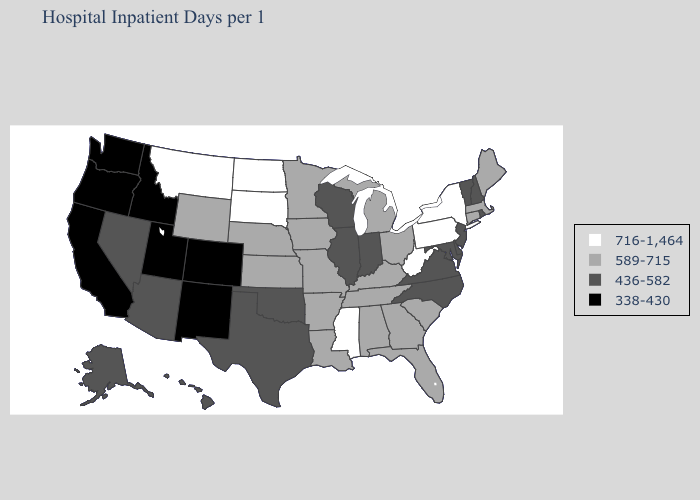Name the states that have a value in the range 716-1,464?
Keep it brief. Mississippi, Montana, New York, North Dakota, Pennsylvania, South Dakota, West Virginia. Name the states that have a value in the range 716-1,464?
Quick response, please. Mississippi, Montana, New York, North Dakota, Pennsylvania, South Dakota, West Virginia. Which states have the lowest value in the USA?
Concise answer only. California, Colorado, Idaho, New Mexico, Oregon, Utah, Washington. Does Louisiana have the highest value in the South?
Be succinct. No. Name the states that have a value in the range 589-715?
Be succinct. Alabama, Arkansas, Connecticut, Florida, Georgia, Iowa, Kansas, Kentucky, Louisiana, Maine, Massachusetts, Michigan, Minnesota, Missouri, Nebraska, Ohio, South Carolina, Tennessee, Wyoming. What is the value of New Jersey?
Write a very short answer. 436-582. Does Illinois have a higher value than Washington?
Write a very short answer. Yes. Name the states that have a value in the range 338-430?
Keep it brief. California, Colorado, Idaho, New Mexico, Oregon, Utah, Washington. Name the states that have a value in the range 338-430?
Quick response, please. California, Colorado, Idaho, New Mexico, Oregon, Utah, Washington. Name the states that have a value in the range 716-1,464?
Short answer required. Mississippi, Montana, New York, North Dakota, Pennsylvania, South Dakota, West Virginia. Is the legend a continuous bar?
Concise answer only. No. Among the states that border New Jersey , which have the lowest value?
Quick response, please. Delaware. Does West Virginia have the same value as New York?
Answer briefly. Yes. Among the states that border Delaware , does New Jersey have the highest value?
Write a very short answer. No. Does the first symbol in the legend represent the smallest category?
Be succinct. No. 